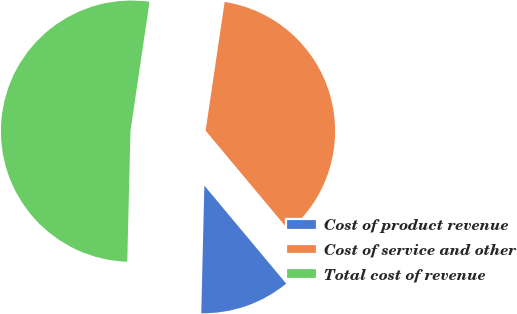Convert chart. <chart><loc_0><loc_0><loc_500><loc_500><pie_chart><fcel>Cost of product revenue<fcel>Cost of service and other<fcel>Total cost of revenue<nl><fcel>11.46%<fcel>36.6%<fcel>51.95%<nl></chart> 